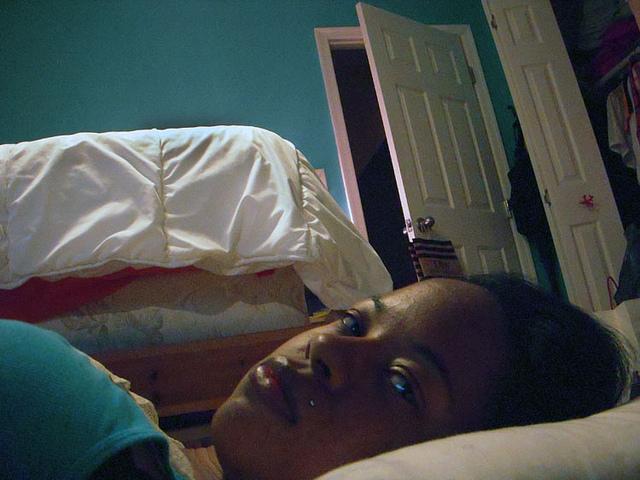How many doors are open?
Answer briefly. 2. What kind of bag is hanging on the door knob?
Quick response, please. Paper. Is the woman sitting or laying down?
Quick response, please. Laying down. How many cats are there?
Answer briefly. 0. 